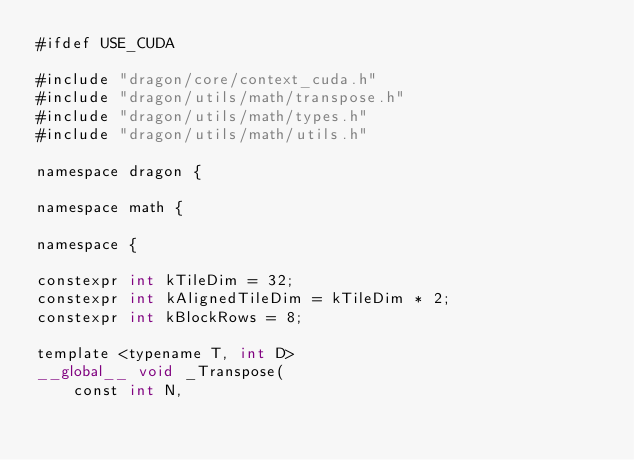Convert code to text. <code><loc_0><loc_0><loc_500><loc_500><_Cuda_>#ifdef USE_CUDA

#include "dragon/core/context_cuda.h"
#include "dragon/utils/math/transpose.h"
#include "dragon/utils/math/types.h"
#include "dragon/utils/math/utils.h"

namespace dragon {

namespace math {

namespace {

constexpr int kTileDim = 32;
constexpr int kAlignedTileDim = kTileDim * 2;
constexpr int kBlockRows = 8;

template <typename T, int D>
__global__ void _Transpose(
    const int N,</code> 